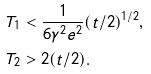<formula> <loc_0><loc_0><loc_500><loc_500>T _ { 1 } & < \frac { 1 } { 6 \gamma ^ { 2 } e ^ { 2 } } ( t / 2 ) ^ { 1 / 2 } , \\ T _ { 2 } & > 2 ( t / 2 ) .</formula> 